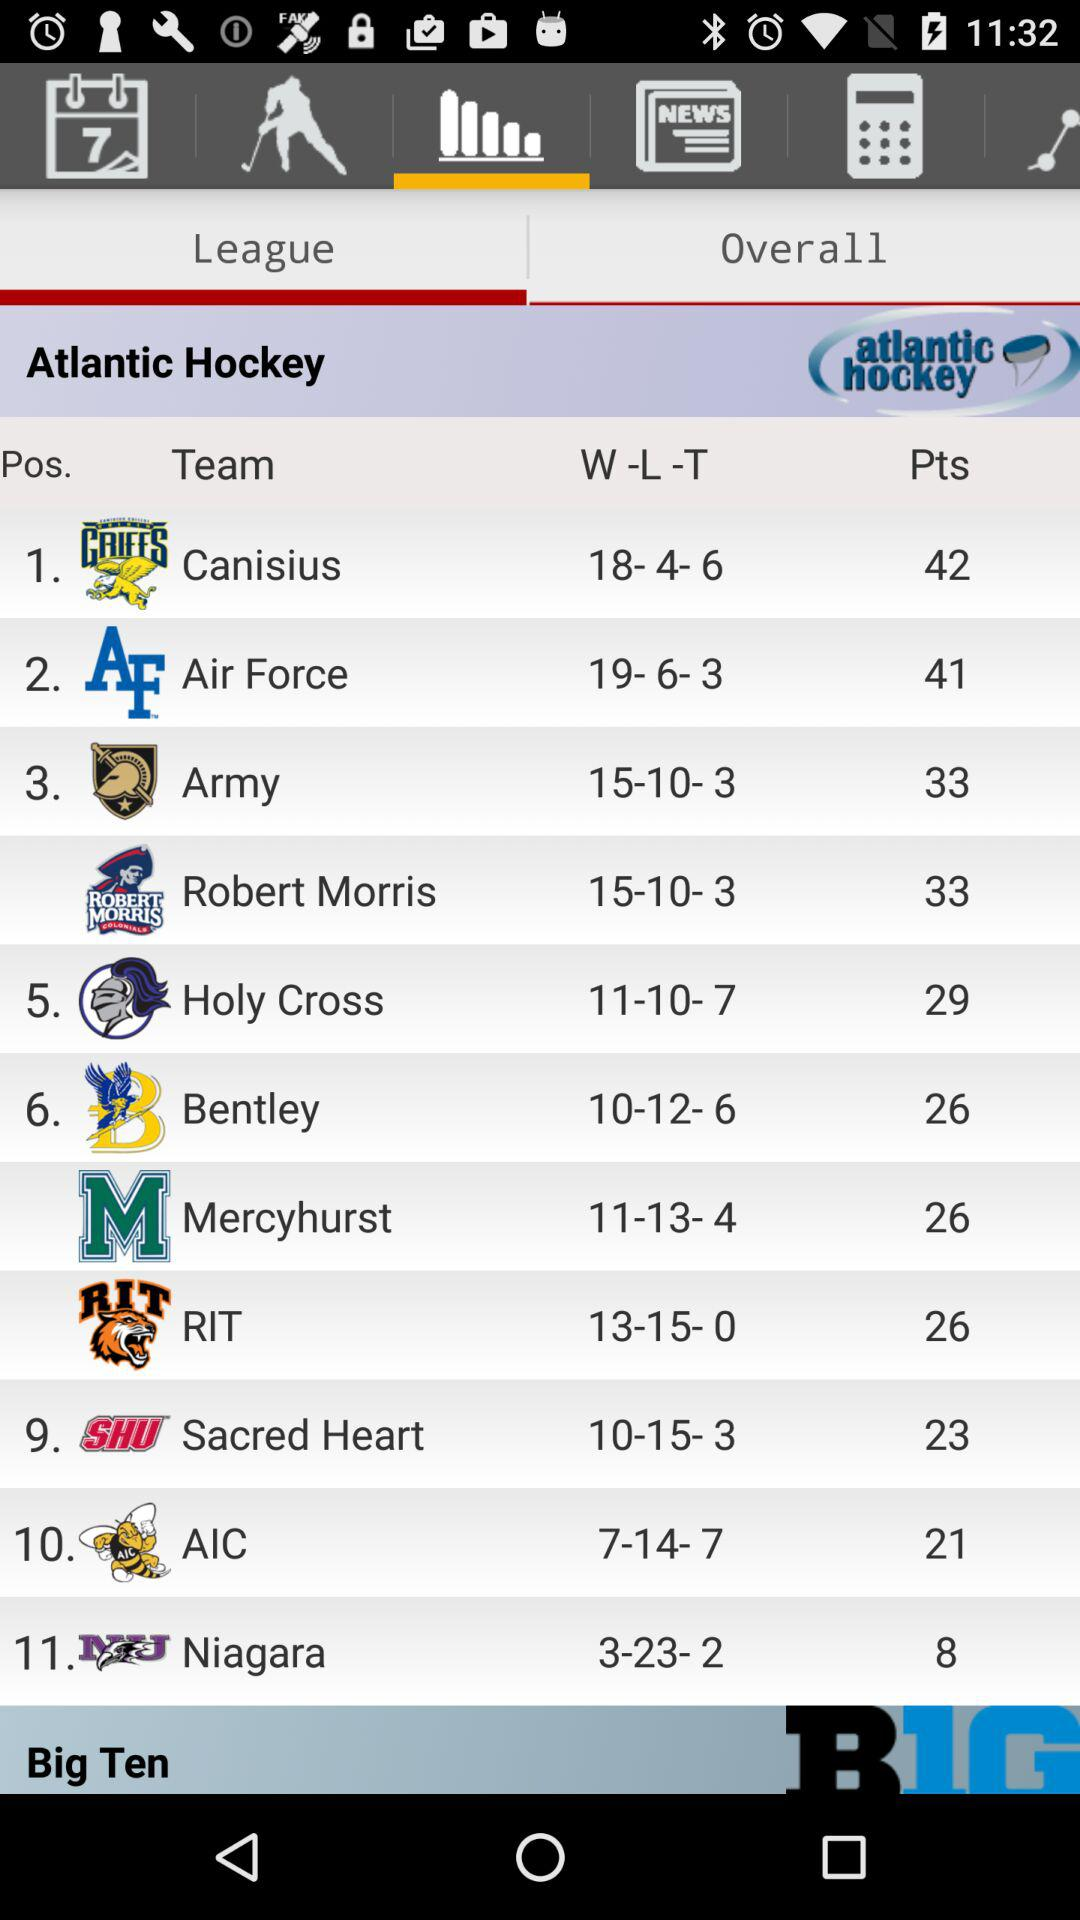Which team has 41 points? The Air Force team has 41 points. 